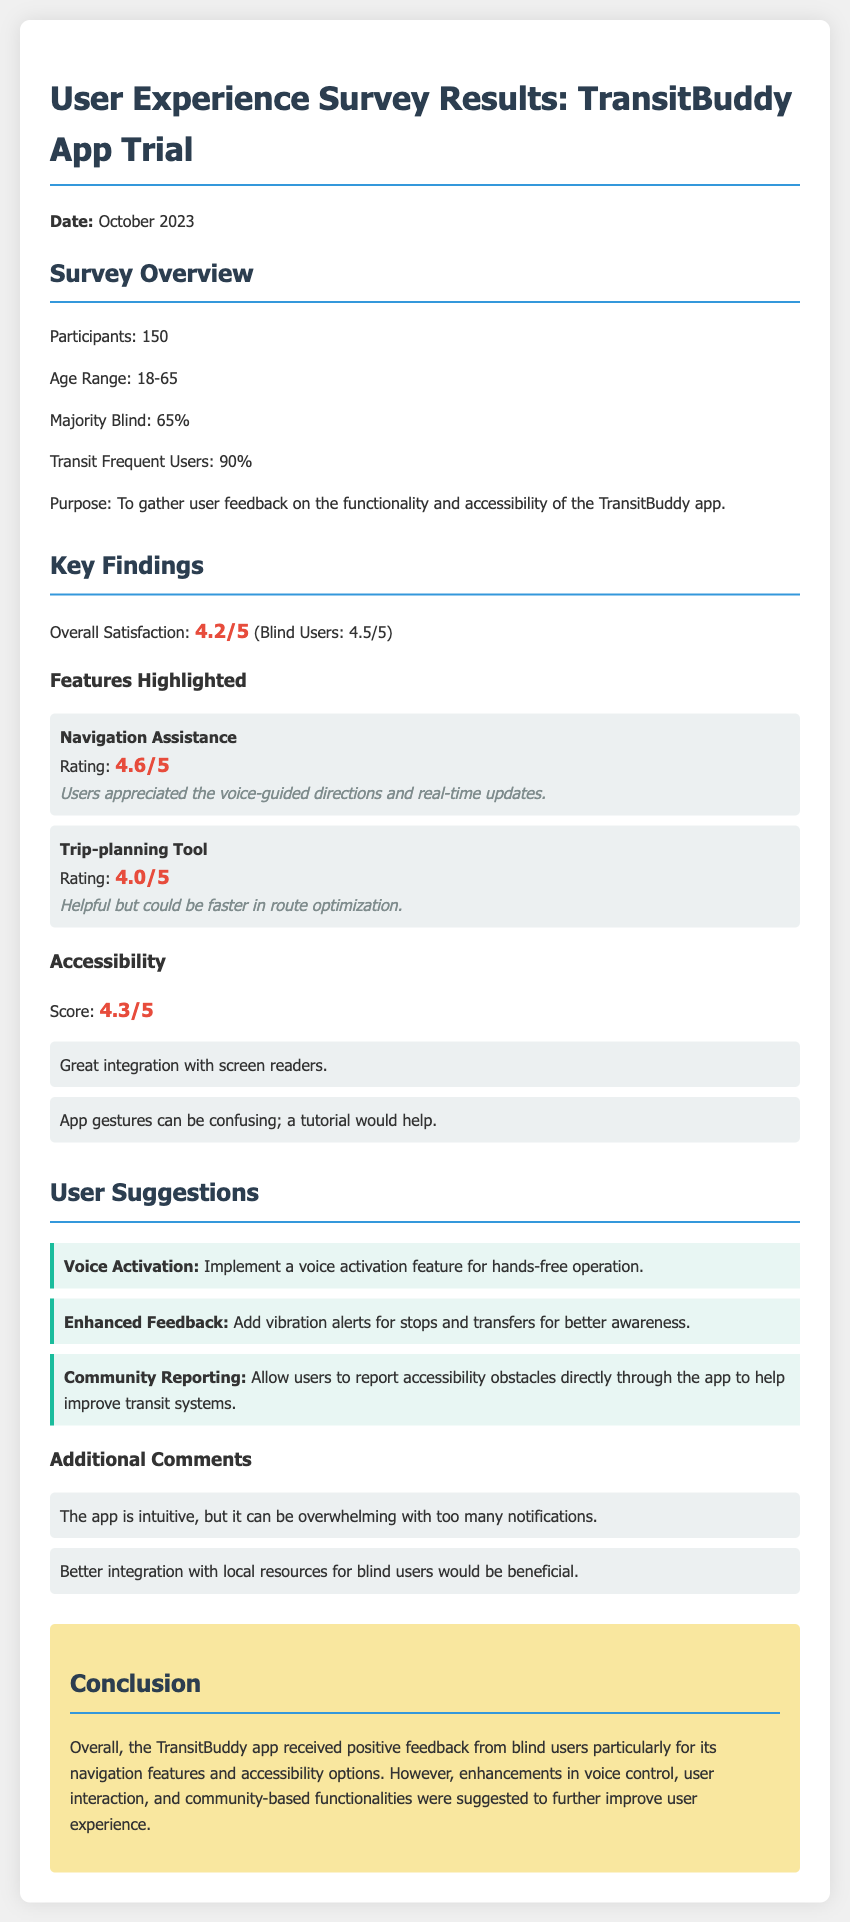What was the overall satisfaction rating from blind users? The overall satisfaction from blind users was rated at 4.5 out of 5 in the survey results.
Answer: 4.5/5 How many participants were in the survey? The document states that there were 150 participants in the user experience survey.
Answer: 150 What feature received the highest rating? The Navigation Assistance feature received the highest rating of 4.6 out of 5 according to the survey results.
Answer: Navigation Assistance What is one suggested enhancement for the app? One suggested enhancement includes implementing a voice activation feature for hands-free operation.
Answer: Voice Activation What was the accessibility score in the survey? The accessibility score in the survey was 4.3 out of 5.
Answer: 4.3/5 What percentage of participants were blind? The document indicates that 65% of the participants were blind users.
Answer: 65% Which feature was rated as helpful but could be faster? The Trip-planning Tool was rated as helpful but could be faster in route optimization.
Answer: Trip-planning Tool What was identified as confusing for users? The app gestures were noted as confusing for users, suggesting a tutorial would help.
Answer: App gestures What is the date of the survey results? The date of the survey results is October 2023.
Answer: October 2023 